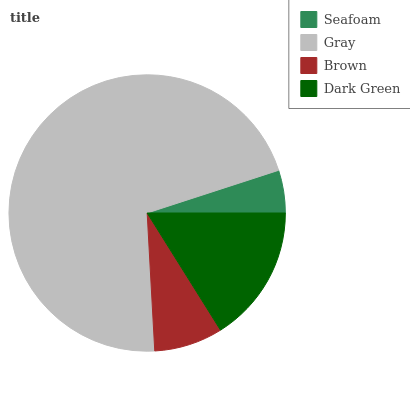Is Seafoam the minimum?
Answer yes or no. Yes. Is Gray the maximum?
Answer yes or no. Yes. Is Brown the minimum?
Answer yes or no. No. Is Brown the maximum?
Answer yes or no. No. Is Gray greater than Brown?
Answer yes or no. Yes. Is Brown less than Gray?
Answer yes or no. Yes. Is Brown greater than Gray?
Answer yes or no. No. Is Gray less than Brown?
Answer yes or no. No. Is Dark Green the high median?
Answer yes or no. Yes. Is Brown the low median?
Answer yes or no. Yes. Is Gray the high median?
Answer yes or no. No. Is Dark Green the low median?
Answer yes or no. No. 